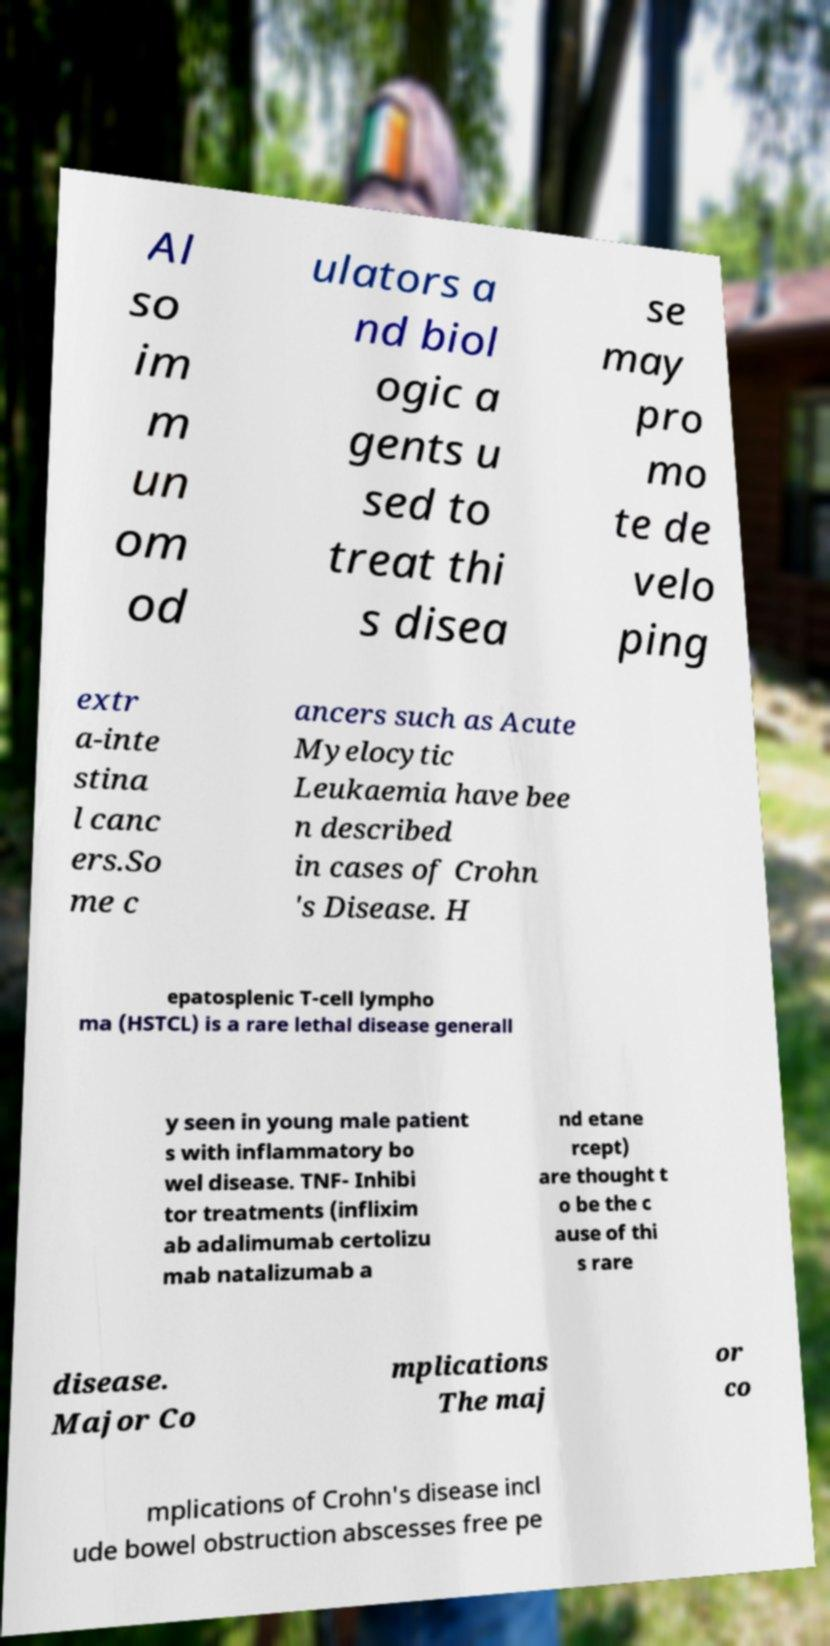Can you accurately transcribe the text from the provided image for me? Al so im m un om od ulators a nd biol ogic a gents u sed to treat thi s disea se may pro mo te de velo ping extr a-inte stina l canc ers.So me c ancers such as Acute Myelocytic Leukaemia have bee n described in cases of Crohn 's Disease. H epatosplenic T-cell lympho ma (HSTCL) is a rare lethal disease generall y seen in young male patient s with inflammatory bo wel disease. TNF- Inhibi tor treatments (inflixim ab adalimumab certolizu mab natalizumab a nd etane rcept) are thought t o be the c ause of thi s rare disease. Major Co mplications The maj or co mplications of Crohn's disease incl ude bowel obstruction abscesses free pe 